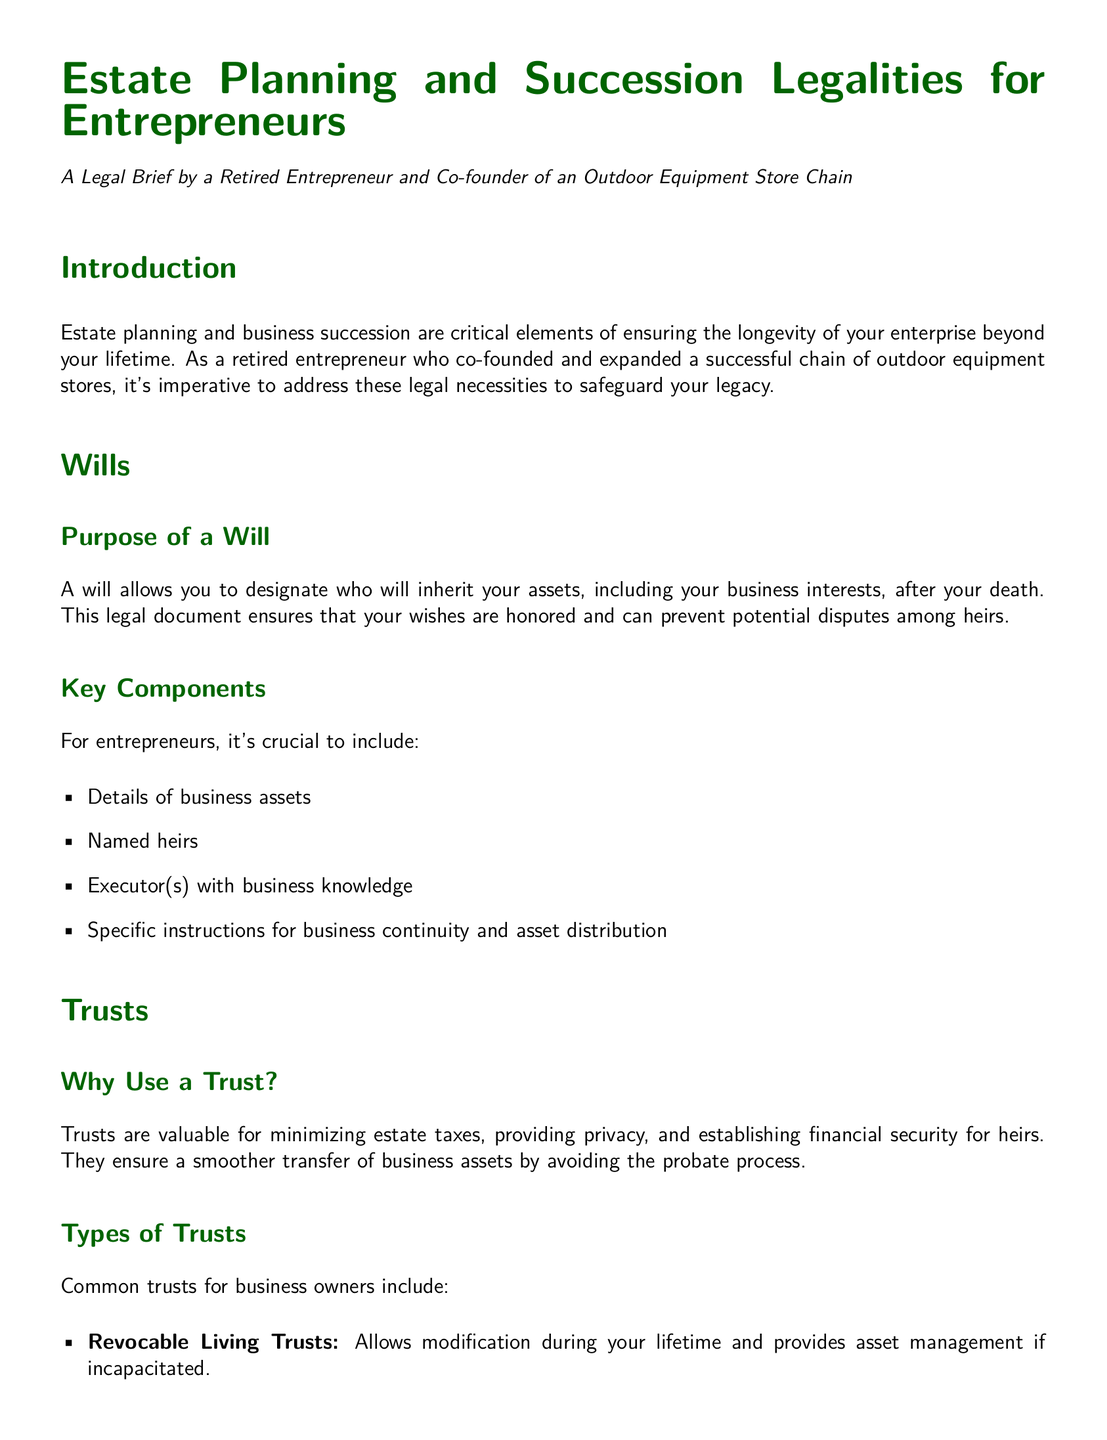What is the purpose of a will? The purpose of a will is to designate who will inherit your assets, including business interests, after your death.
Answer: Designate heirs What type of trust allows modification during your lifetime? Revocable living trusts can be modified during your lifetime.
Answer: Revocable Living Trusts What should you include in your will as an entrepreneur? Entrepreneurs should include details of business assets, named heirs, executor(s) with business knowledge, and instructions for continuity and distribution.
Answer: Business assets, named heirs, executor(s), instructions What is a buy-sell agreement? A buy-sell agreement is a legally binding agreement outlining procedures for a co-owner's interest to be bought out in the event of death, disability, or retirement.
Answer: Legally binding agreement What is a key family consideration when distributing business assets? A key consideration is whether the heirs are willing and able to manage the business.
Answer: Willing and able How do trusts benefit estate planning? Trusts minimize estate taxes, provide privacy, and establish financial security for heirs.
Answer: Minimize estate taxes, provide privacy, financial security What type of trust provides tax benefits and asset protection? Irrevocable trusts offer tax benefits and asset protection.
Answer: Irrevocable Trusts What can be done if heirs are not interested in running the business? If heirs are not interested, an option is to sell the business.
Answer: Sell the business 